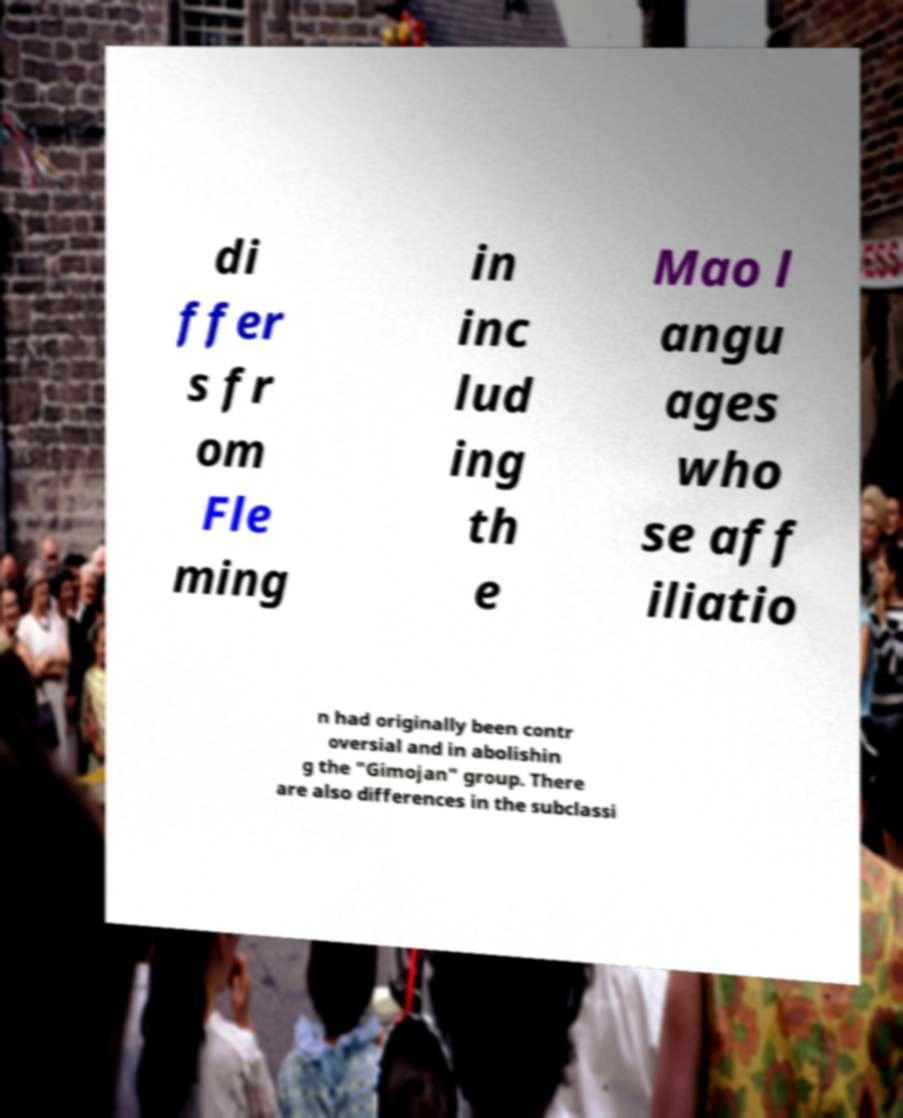For documentation purposes, I need the text within this image transcribed. Could you provide that? di ffer s fr om Fle ming in inc lud ing th e Mao l angu ages who se aff iliatio n had originally been contr oversial and in abolishin g the "Gimojan" group. There are also differences in the subclassi 